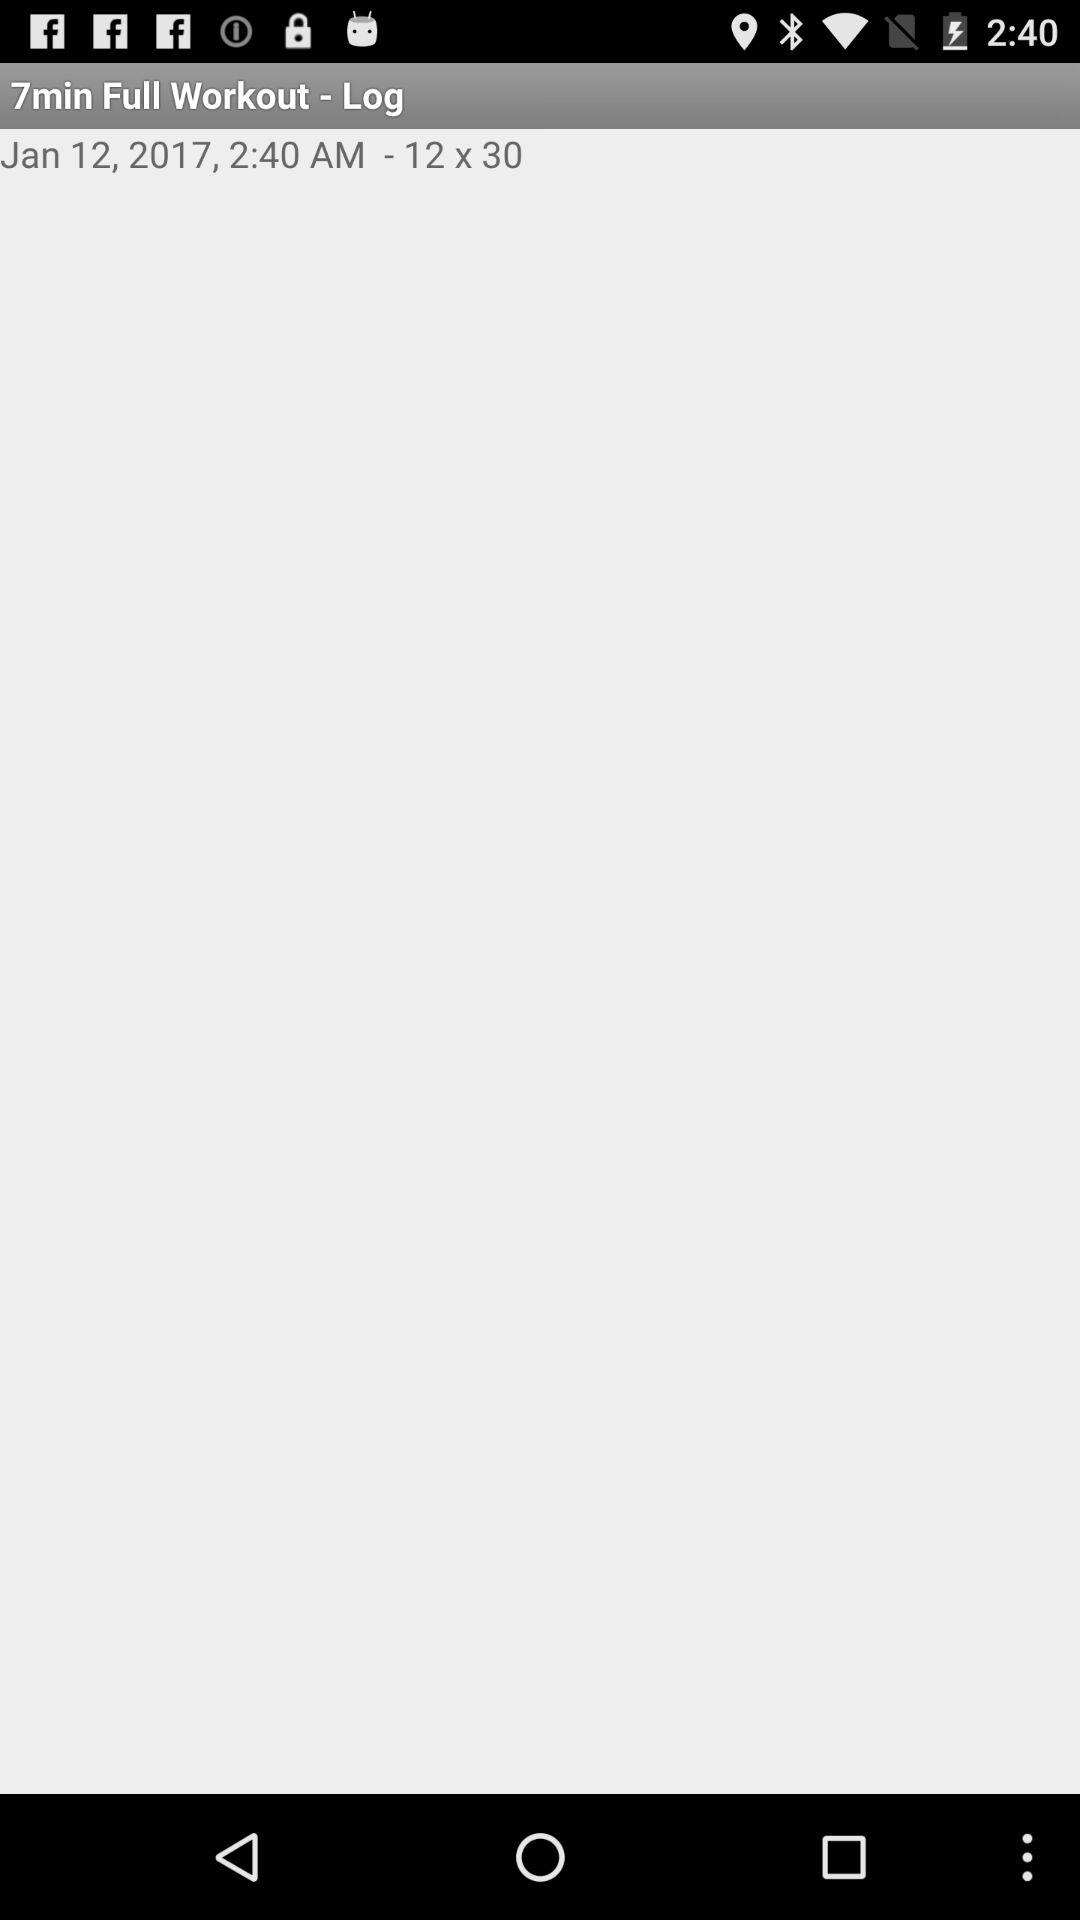What is the dimension? The dimension is 12 x 30. 